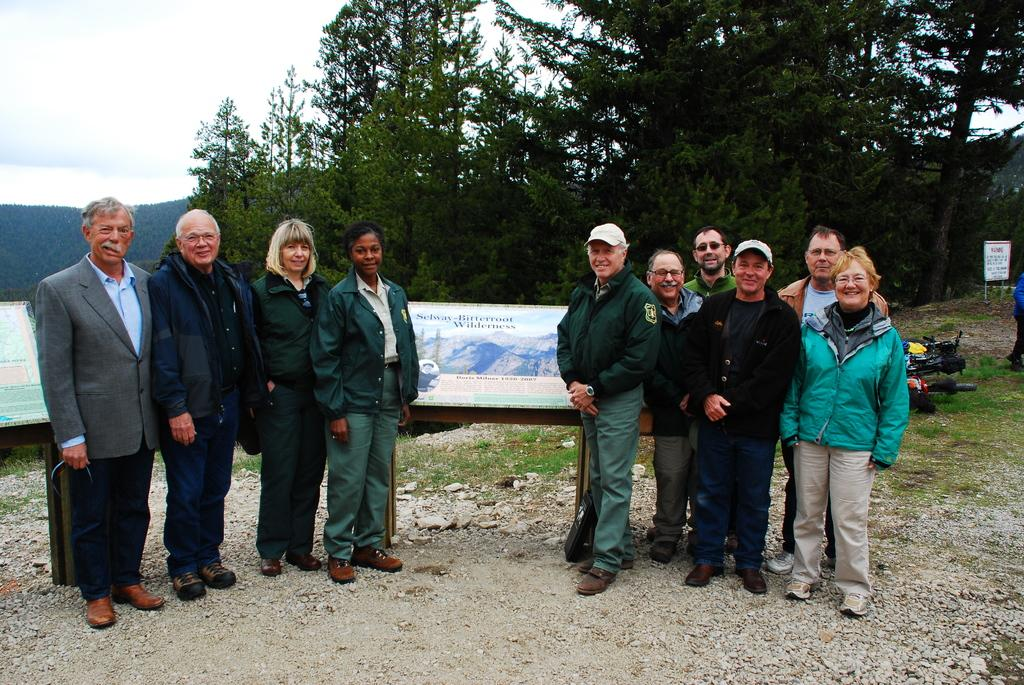How many groups of persons are visible in the image? There are two groups of persons standing and smiling on the ground. What can be seen in the background of the image? There are two hoardings, trees, a mountain, and clouds in the sky visible in the background. What are the persons in the image doing? The persons in the image are standing and smiling. What time of day does the image depict, specifically in the afternoon? The provided facts do not mention the time of day, so it cannot be determined if the image depicts the afternoon. What is the desire of the hill in the image? There is no hill present in the image, so it is not possible to determine the desire of a hill. 